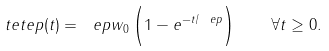<formula> <loc_0><loc_0><loc_500><loc_500>\ t e t e p ( t ) = \ e p w _ { 0 } \left ( 1 - e ^ { - t / \ e p } \strut \right ) \quad \forall t \geq 0 .</formula> 